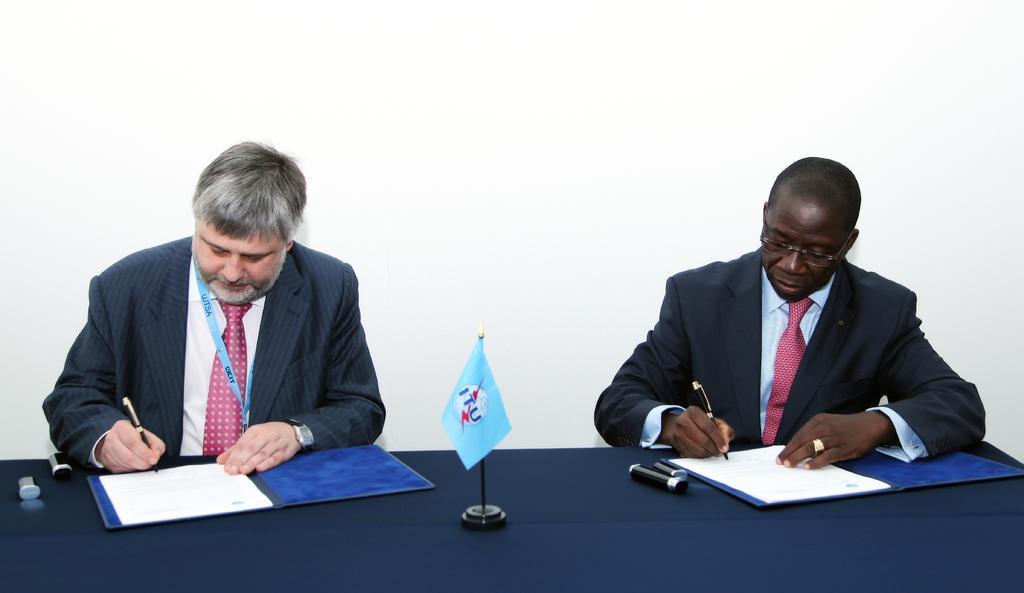Describe this image in one or two sentences. In this image I can see two people are sitting and holding pens. I can see a flag,files,papers and few objects on the table. Background is in white color. 